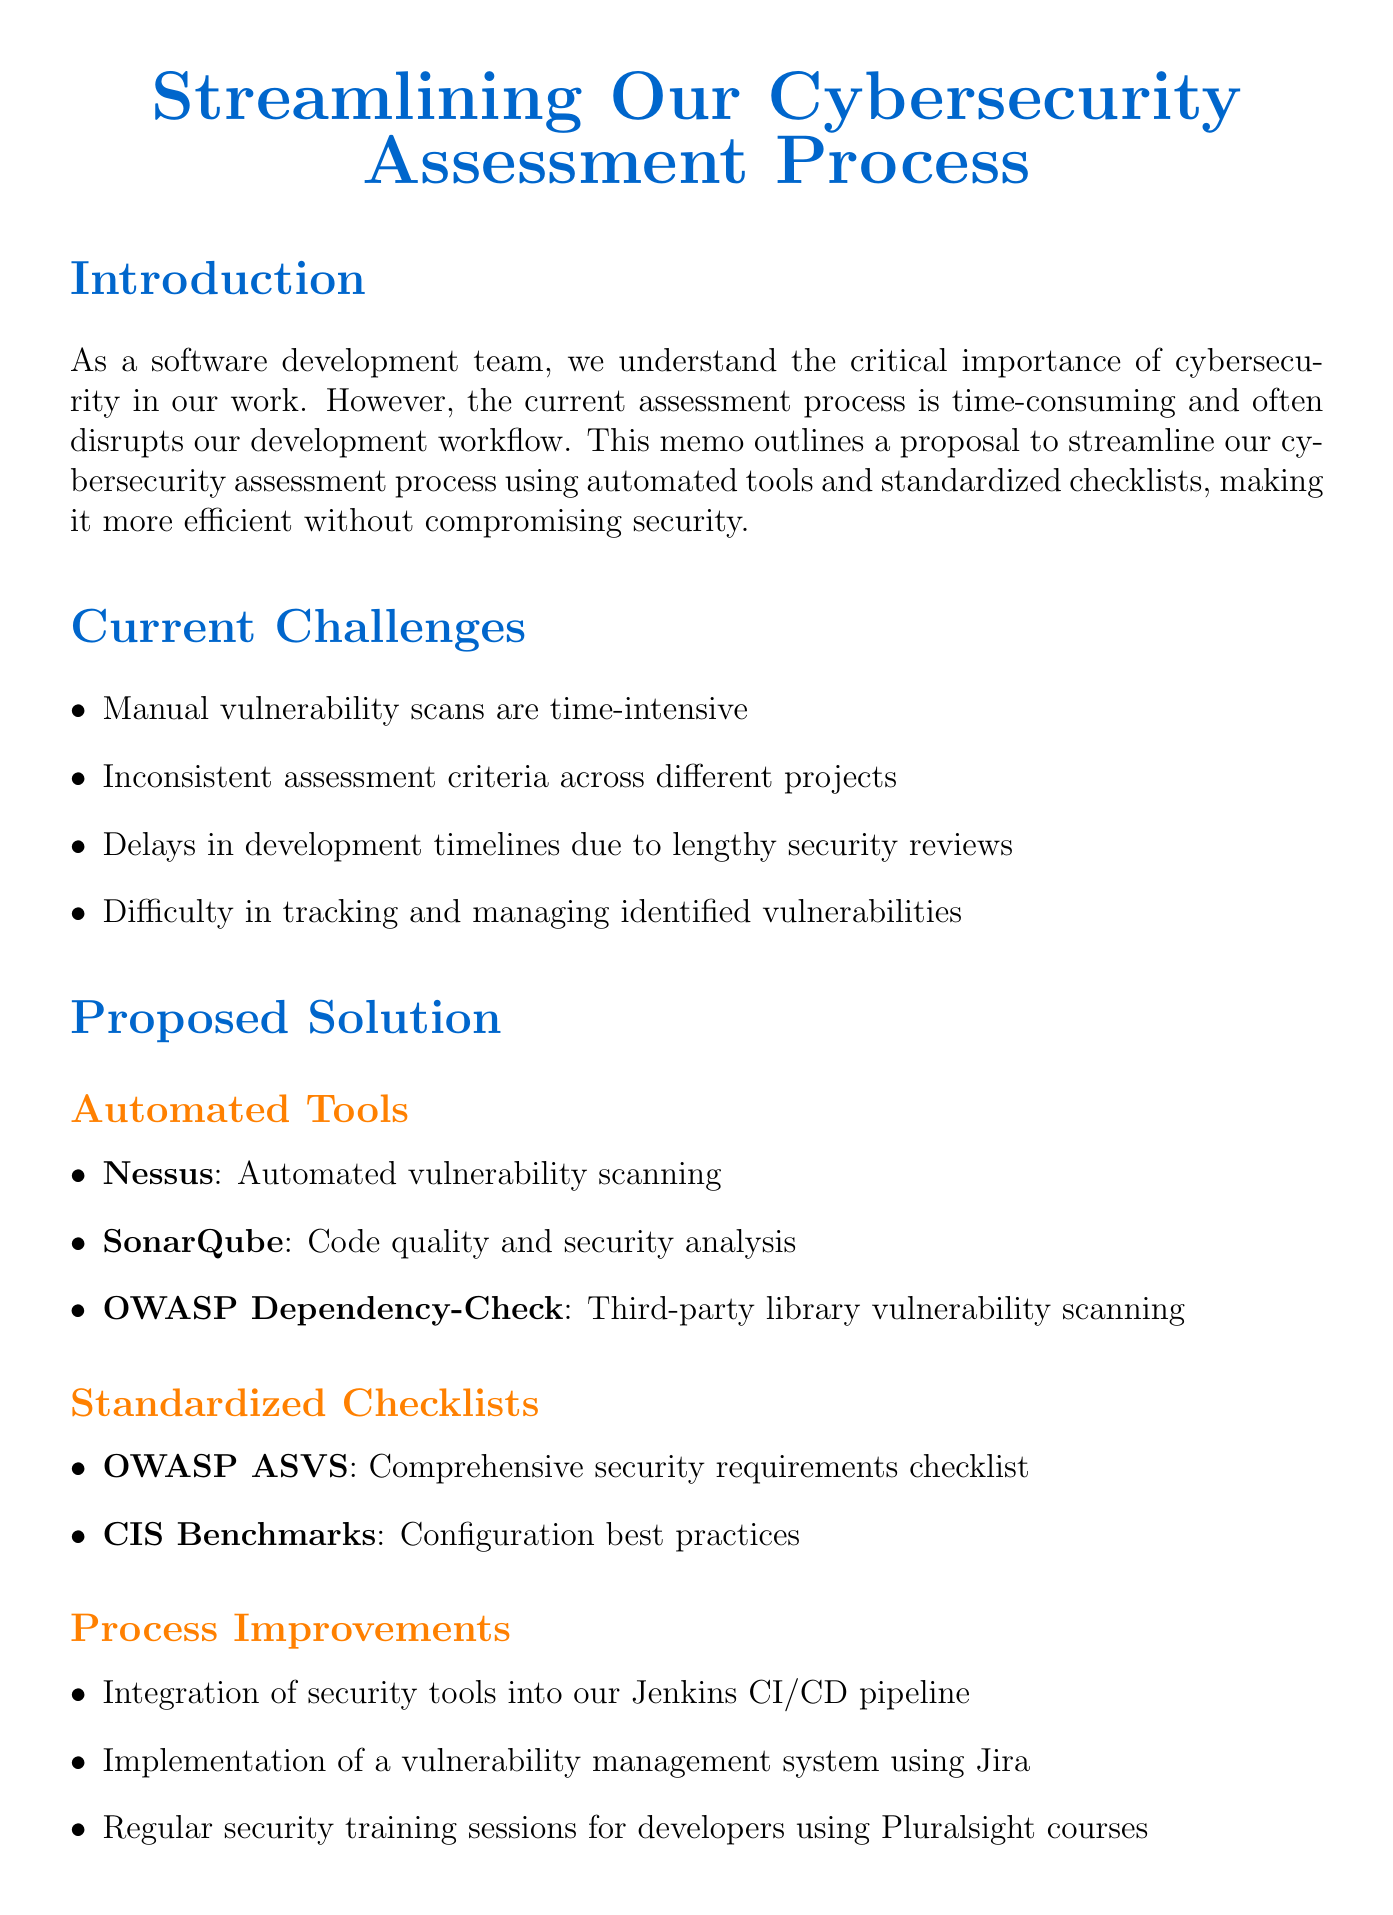what is the title of the memo? The title of the memo is stated at the beginning of the document.
Answer: Streamlining Our Cybersecurity Assessment Process what is the main purpose of the memo? The purpose outlines the intention to make the assessment process more efficient while maintaining security.
Answer: To streamline our cybersecurity assessment process how many automated tools are proposed in the document? The document lists several automated tools in the proposed solution section.
Answer: Three what is the expected reduction in assessment time? The document explicitly mentions the expected decrease in assessment duration.
Answer: Up to 60% which tool is used for automated vulnerability scanning? The document specifies each tool along with its purpose.
Answer: Nessus what is one benefit of using SonarQube? The benefit of this tool is specifically mentioned in the proposed solution section.
Answer: Integrates directly into our CI/CD pipeline for continuous assessment how long does the "Tool Selection and Setup" phase last? The duration for this phase is clearly indicated in the implementation plan.
Answer: Two weeks what is the name of the checklist that includes security requirements? This checklist is mentioned in the standardized checklists subsection of the proposed solution.
Answer: OWASP Application Security Verification Standard (ASVS) what is one process improvement mentioned in the memo? The document lists specific improvements in the process improvement section.
Answer: Integration of security tools into our Jenkins CI/CD pipeline 